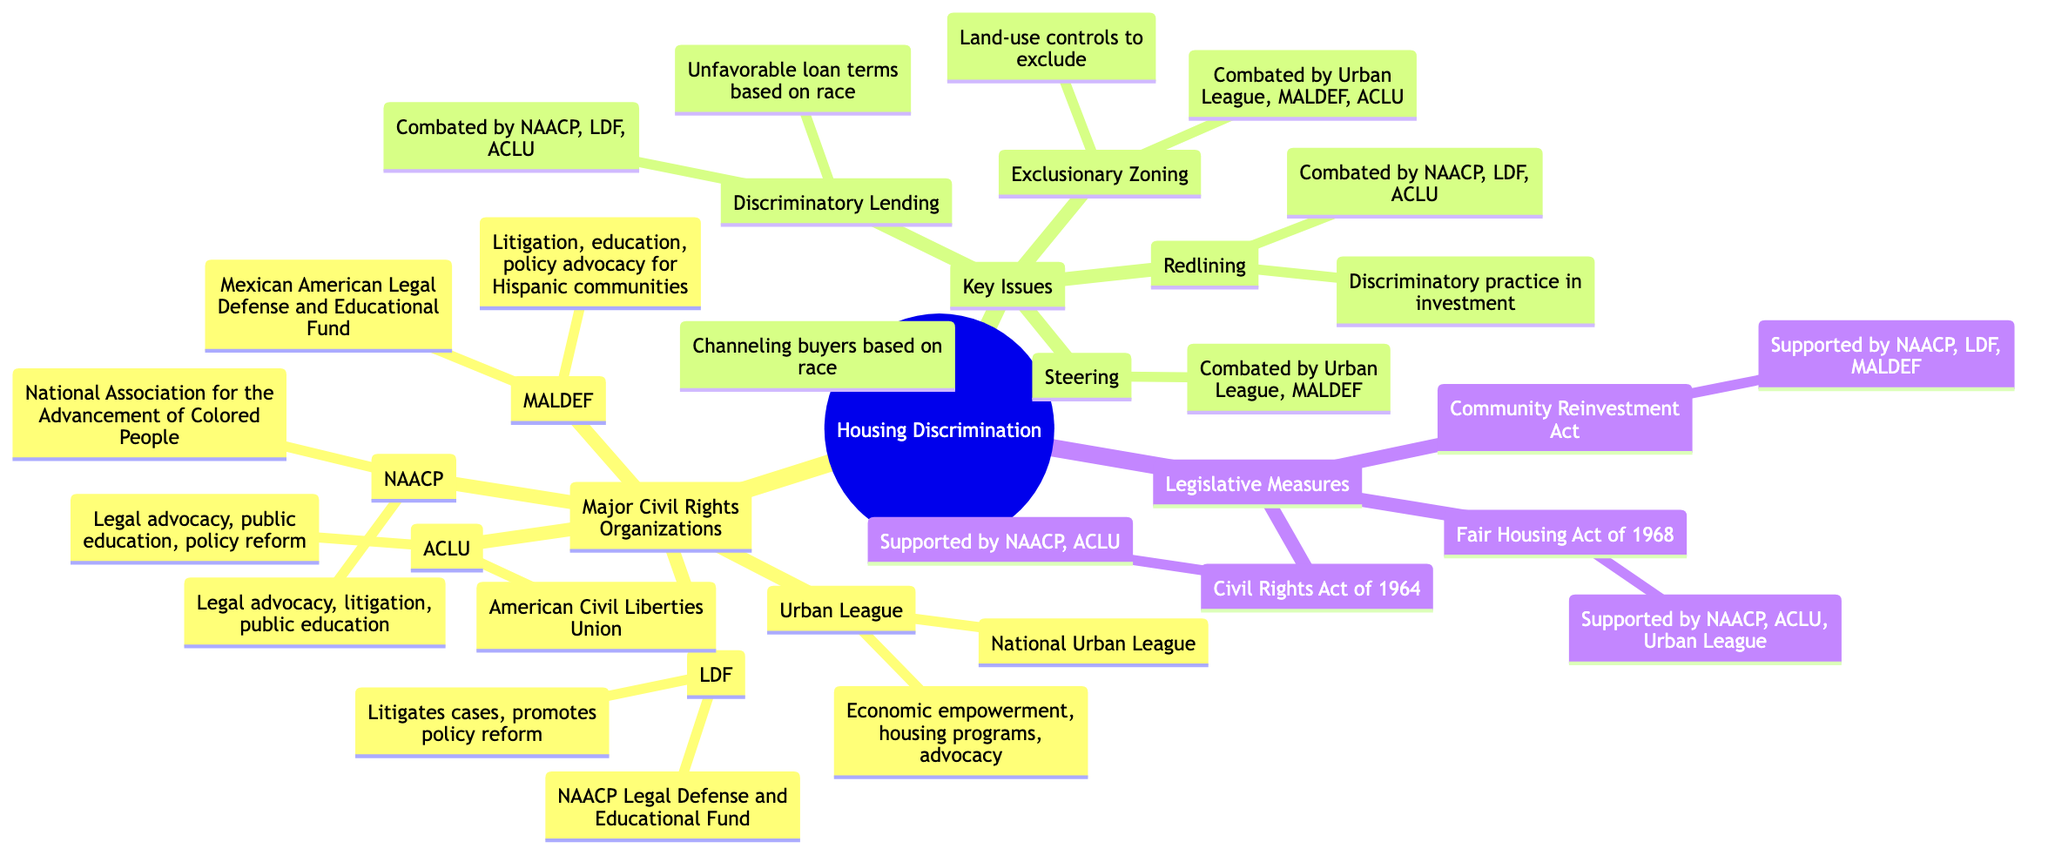What is the full name of NAACP? The diagram states that NAACP stands for the National Association for the Advancement of Colored People. This information is directly linked to the NAACP node, which gives its full name.
Answer: National Association for the Advancement of Colored People How many organizations are focused on combating Redlining? By counting the organizations listed under Redlining, which are NAACP, LDF, and ACLU, we find there are three organizations addressing this issue.
Answer: 3 What role does the Urban League play in combating housing discrimination? The diagram highlights that the Urban League is involved in economic empowerment, housing programs, and advocacy. These functions illustrate the organization's commitment to combating housing discrimination.
Answer: Economic empowerment, housing programs, advocacy Which legislative measure is supported by both NAACP and ACLU? The diagram shows that both the NAACP and ACLU support the Fair Housing Act of 1968 and the Civil Rights Act of 1964, therefore indicating both organizations align on these legislative measures.
Answer: Fair Housing Act of 1968, Civil Rights Act of 1964 What is the definition of Steering in the context of housing discrimination? The definition of Steering is noted in the diagram as "Channeling prospective buyers or renters to particular neighborhoods based on race," which explains the discriminatory nature of this practice.
Answer: Channeling prospective buyers or renters to particular neighborhoods based on race Name one organization that combats Exclusionary Zoning. According to the diagram, the Urban League, MALDEF, and ACLU are all involved in combating Exclusionary Zoning, so naming any one of these organizations is correct.
Answer: Urban League (or MALDEF or ACLU) How many key issues in housing discrimination are identified in the diagram? The diagram identifies four key issues in housing discrimination: Redlining, Steering, Discriminatory Lending, and Exclusionary Zoning. Adding these gives us a total of four issues identified.
Answer: 4 What type of advocacy is the ACLU involved in regarding housing discrimination? The diagram details that the ACLU is engaged in legal advocacy, public education, and policy reform concerning fair housing, indicating its multifaceted approach to advocacy in this area.
Answer: Legal advocacy, public education, policy reform Which organization promotes policy reform specifically related to housing discrimination? The NAACP Legal Defense and Educational Fund (LDF) is mentioned in the diagram as promoting policy reform, indicating its active role in this area concerning housing discrimination.
Answer: NAACP Legal Defense and Educational Fund 